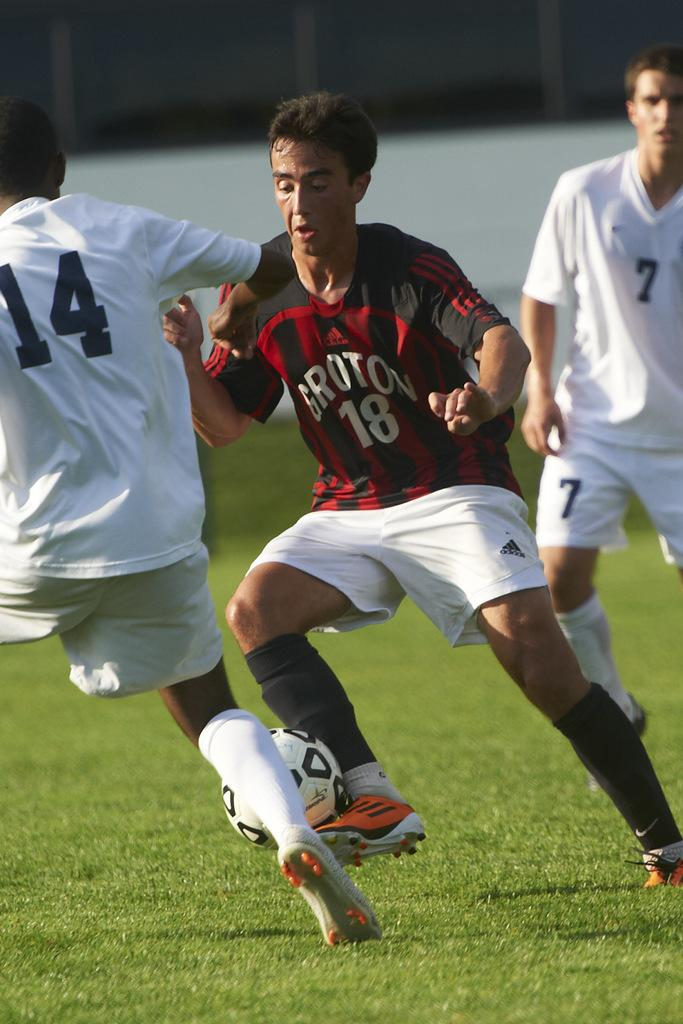How many players are involved in the game in the image? There are three players in the image. What sport are the players engaged in? The players are playing football. Where is the football game taking place? The football game is taking place in a playground. Can you describe the condition of the grass in the playground? The grass in the playground is fresh and green. What type of cough medicine is being passed around by the players during the game? There is no cough medicine or any reference to coughing in the image; the players are focused on playing football. 